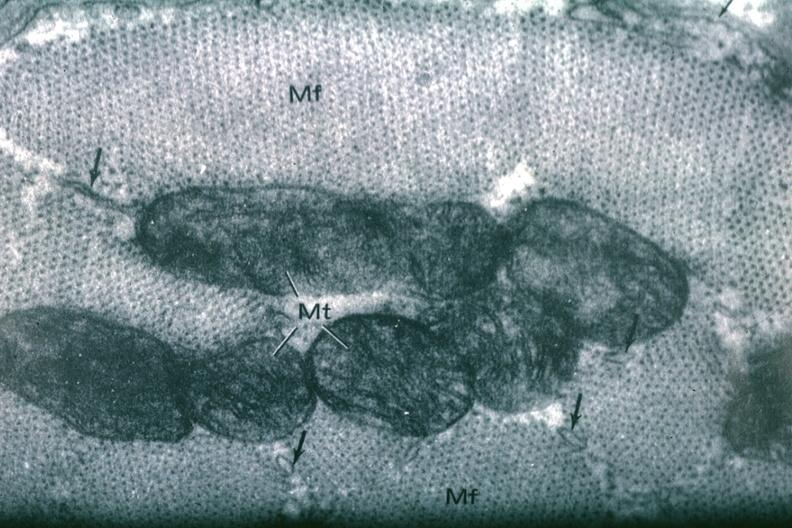what is present?
Answer the question using a single word or phrase. Myocardium 